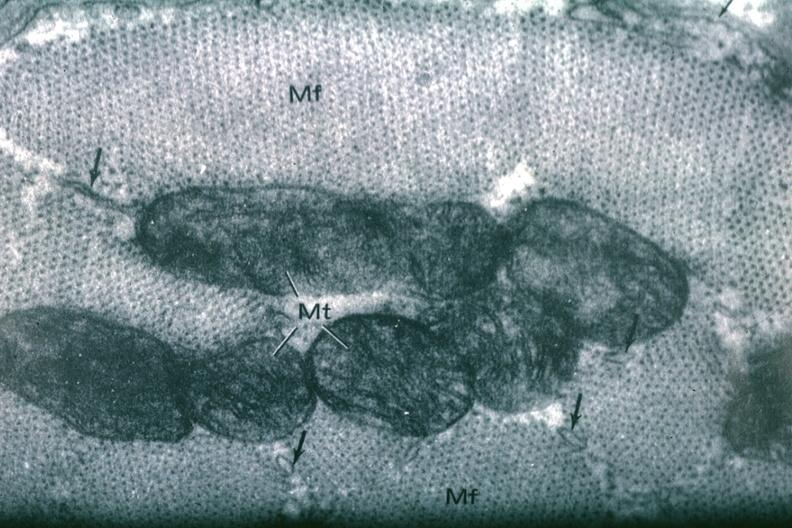what is present?
Answer the question using a single word or phrase. Myocardium 